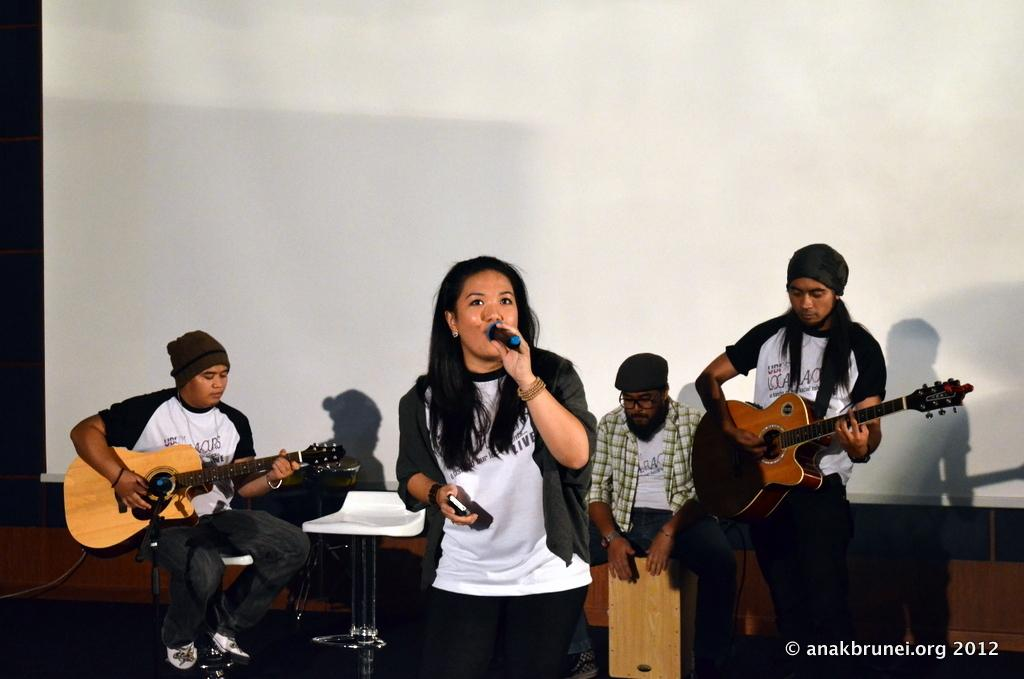How many people are in the image? There are four people in the image. What are two of the people doing? Two of them are playing guitar. What is the third person doing? One person is singing. What is the fourth person doing? One person is beating the band. What can be seen in the background of the image? There is a wall in the background of the image. Can you see a snake slithering on the wall in the image? No, there is no snake present in the image. Are there any monkeys playing instruments in the image? No, there are no monkeys present in the image. 